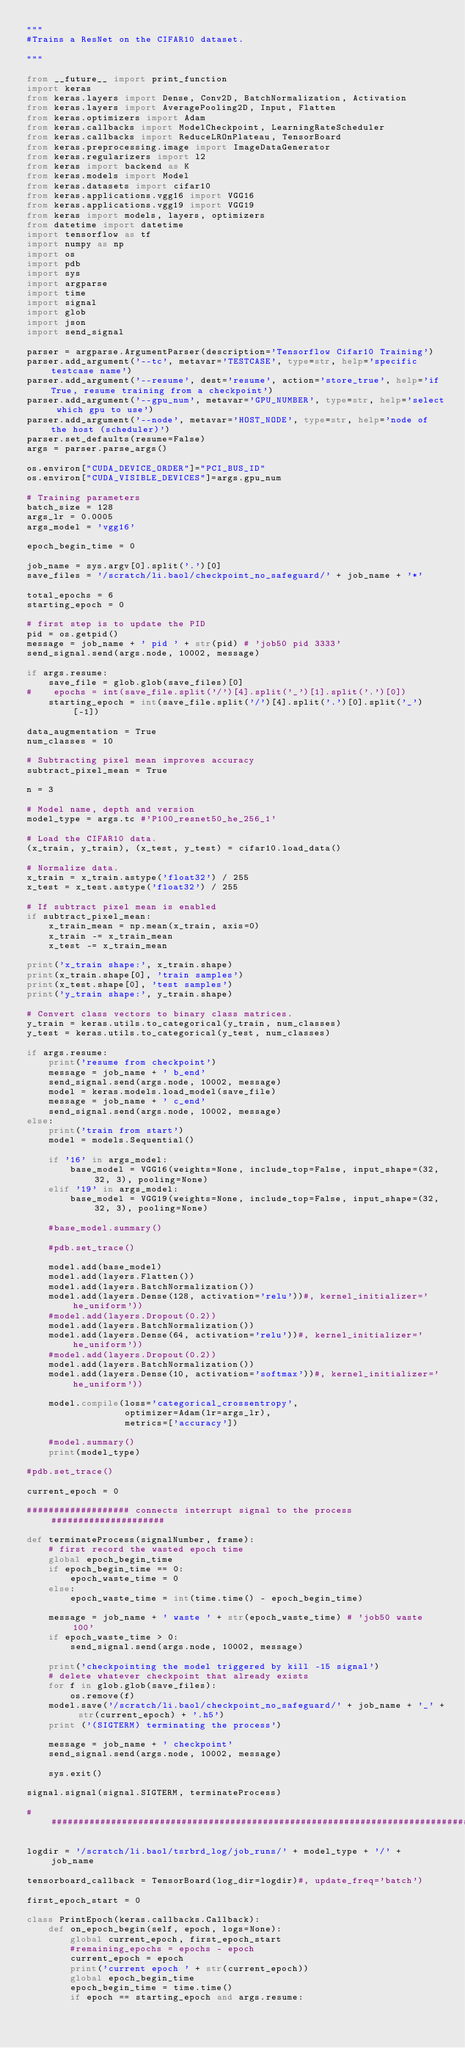Convert code to text. <code><loc_0><loc_0><loc_500><loc_500><_Python_>"""
#Trains a ResNet on the CIFAR10 dataset.

"""

from __future__ import print_function
import keras
from keras.layers import Dense, Conv2D, BatchNormalization, Activation
from keras.layers import AveragePooling2D, Input, Flatten
from keras.optimizers import Adam
from keras.callbacks import ModelCheckpoint, LearningRateScheduler
from keras.callbacks import ReduceLROnPlateau, TensorBoard
from keras.preprocessing.image import ImageDataGenerator
from keras.regularizers import l2
from keras import backend as K
from keras.models import Model
from keras.datasets import cifar10
from keras.applications.vgg16 import VGG16
from keras.applications.vgg19 import VGG19
from keras import models, layers, optimizers
from datetime import datetime
import tensorflow as tf
import numpy as np
import os
import pdb
import sys
import argparse
import time
import signal
import glob
import json
import send_signal

parser = argparse.ArgumentParser(description='Tensorflow Cifar10 Training')
parser.add_argument('--tc', metavar='TESTCASE', type=str, help='specific testcase name')
parser.add_argument('--resume', dest='resume', action='store_true', help='if True, resume training from a checkpoint')
parser.add_argument('--gpu_num', metavar='GPU_NUMBER', type=str, help='select which gpu to use')
parser.add_argument('--node', metavar='HOST_NODE', type=str, help='node of the host (scheduler)')
parser.set_defaults(resume=False)
args = parser.parse_args()

os.environ["CUDA_DEVICE_ORDER"]="PCI_BUS_ID"
os.environ["CUDA_VISIBLE_DEVICES"]=args.gpu_num

# Training parameters
batch_size = 128
args_lr = 0.0005
args_model = 'vgg16'

epoch_begin_time = 0

job_name = sys.argv[0].split('.')[0]
save_files = '/scratch/li.baol/checkpoint_no_safeguard/' + job_name + '*'

total_epochs = 6
starting_epoch = 0

# first step is to update the PID
pid = os.getpid()
message = job_name + ' pid ' + str(pid) # 'job50 pid 3333'
send_signal.send(args.node, 10002, message)

if args.resume:
    save_file = glob.glob(save_files)[0]
#    epochs = int(save_file.split('/')[4].split('_')[1].split('.')[0])
    starting_epoch = int(save_file.split('/')[4].split('.')[0].split('_')[-1])

data_augmentation = True
num_classes = 10

# Subtracting pixel mean improves accuracy
subtract_pixel_mean = True

n = 3

# Model name, depth and version
model_type = args.tc #'P100_resnet50_he_256_1'

# Load the CIFAR10 data.
(x_train, y_train), (x_test, y_test) = cifar10.load_data()

# Normalize data.
x_train = x_train.astype('float32') / 255
x_test = x_test.astype('float32') / 255

# If subtract pixel mean is enabled
if subtract_pixel_mean:
    x_train_mean = np.mean(x_train, axis=0)
    x_train -= x_train_mean
    x_test -= x_train_mean

print('x_train shape:', x_train.shape)
print(x_train.shape[0], 'train samples')
print(x_test.shape[0], 'test samples')
print('y_train shape:', y_train.shape)

# Convert class vectors to binary class matrices.
y_train = keras.utils.to_categorical(y_train, num_classes)
y_test = keras.utils.to_categorical(y_test, num_classes)

if args.resume:
    print('resume from checkpoint')
    message = job_name + ' b_end'
    send_signal.send(args.node, 10002, message)
    model = keras.models.load_model(save_file)
    message = job_name + ' c_end'
    send_signal.send(args.node, 10002, message)
else:
    print('train from start')
    model = models.Sequential()
    
    if '16' in args_model:
        base_model = VGG16(weights=None, include_top=False, input_shape=(32, 32, 3), pooling=None)
    elif '19' in args_model:
        base_model = VGG19(weights=None, include_top=False, input_shape=(32, 32, 3), pooling=None)
    
    #base_model.summary()
    
    #pdb.set_trace()
    
    model.add(base_model)
    model.add(layers.Flatten())
    model.add(layers.BatchNormalization())
    model.add(layers.Dense(128, activation='relu'))#, kernel_initializer='he_uniform'))
    #model.add(layers.Dropout(0.2))
    model.add(layers.BatchNormalization())
    model.add(layers.Dense(64, activation='relu'))#, kernel_initializer='he_uniform'))
    #model.add(layers.Dropout(0.2))
    model.add(layers.BatchNormalization())
    model.add(layers.Dense(10, activation='softmax'))#, kernel_initializer='he_uniform'))
    
    model.compile(loss='categorical_crossentropy',
                  optimizer=Adam(lr=args_lr),
                  metrics=['accuracy'])
    
    #model.summary()
    print(model_type)

#pdb.set_trace()

current_epoch = 0

################### connects interrupt signal to the process #####################

def terminateProcess(signalNumber, frame):
    # first record the wasted epoch time
    global epoch_begin_time
    if epoch_begin_time == 0:
        epoch_waste_time = 0
    else:
        epoch_waste_time = int(time.time() - epoch_begin_time)

    message = job_name + ' waste ' + str(epoch_waste_time) # 'job50 waste 100'
    if epoch_waste_time > 0:
        send_signal.send(args.node, 10002, message)

    print('checkpointing the model triggered by kill -15 signal')
    # delete whatever checkpoint that already exists
    for f in glob.glob(save_files):
        os.remove(f)
    model.save('/scratch/li.baol/checkpoint_no_safeguard/' + job_name + '_' + str(current_epoch) + '.h5')
    print ('(SIGTERM) terminating the process')

    message = job_name + ' checkpoint'
    send_signal.send(args.node, 10002, message)

    sys.exit()

signal.signal(signal.SIGTERM, terminateProcess)

#################################################################################

logdir = '/scratch/li.baol/tsrbrd_log/job_runs/' + model_type + '/' + job_name

tensorboard_callback = TensorBoard(log_dir=logdir)#, update_freq='batch')

first_epoch_start = 0

class PrintEpoch(keras.callbacks.Callback):
    def on_epoch_begin(self, epoch, logs=None):
        global current_epoch, first_epoch_start
        #remaining_epochs = epochs - epoch
        current_epoch = epoch
        print('current epoch ' + str(current_epoch))
        global epoch_begin_time
        epoch_begin_time = time.time()
        if epoch == starting_epoch and args.resume:</code> 